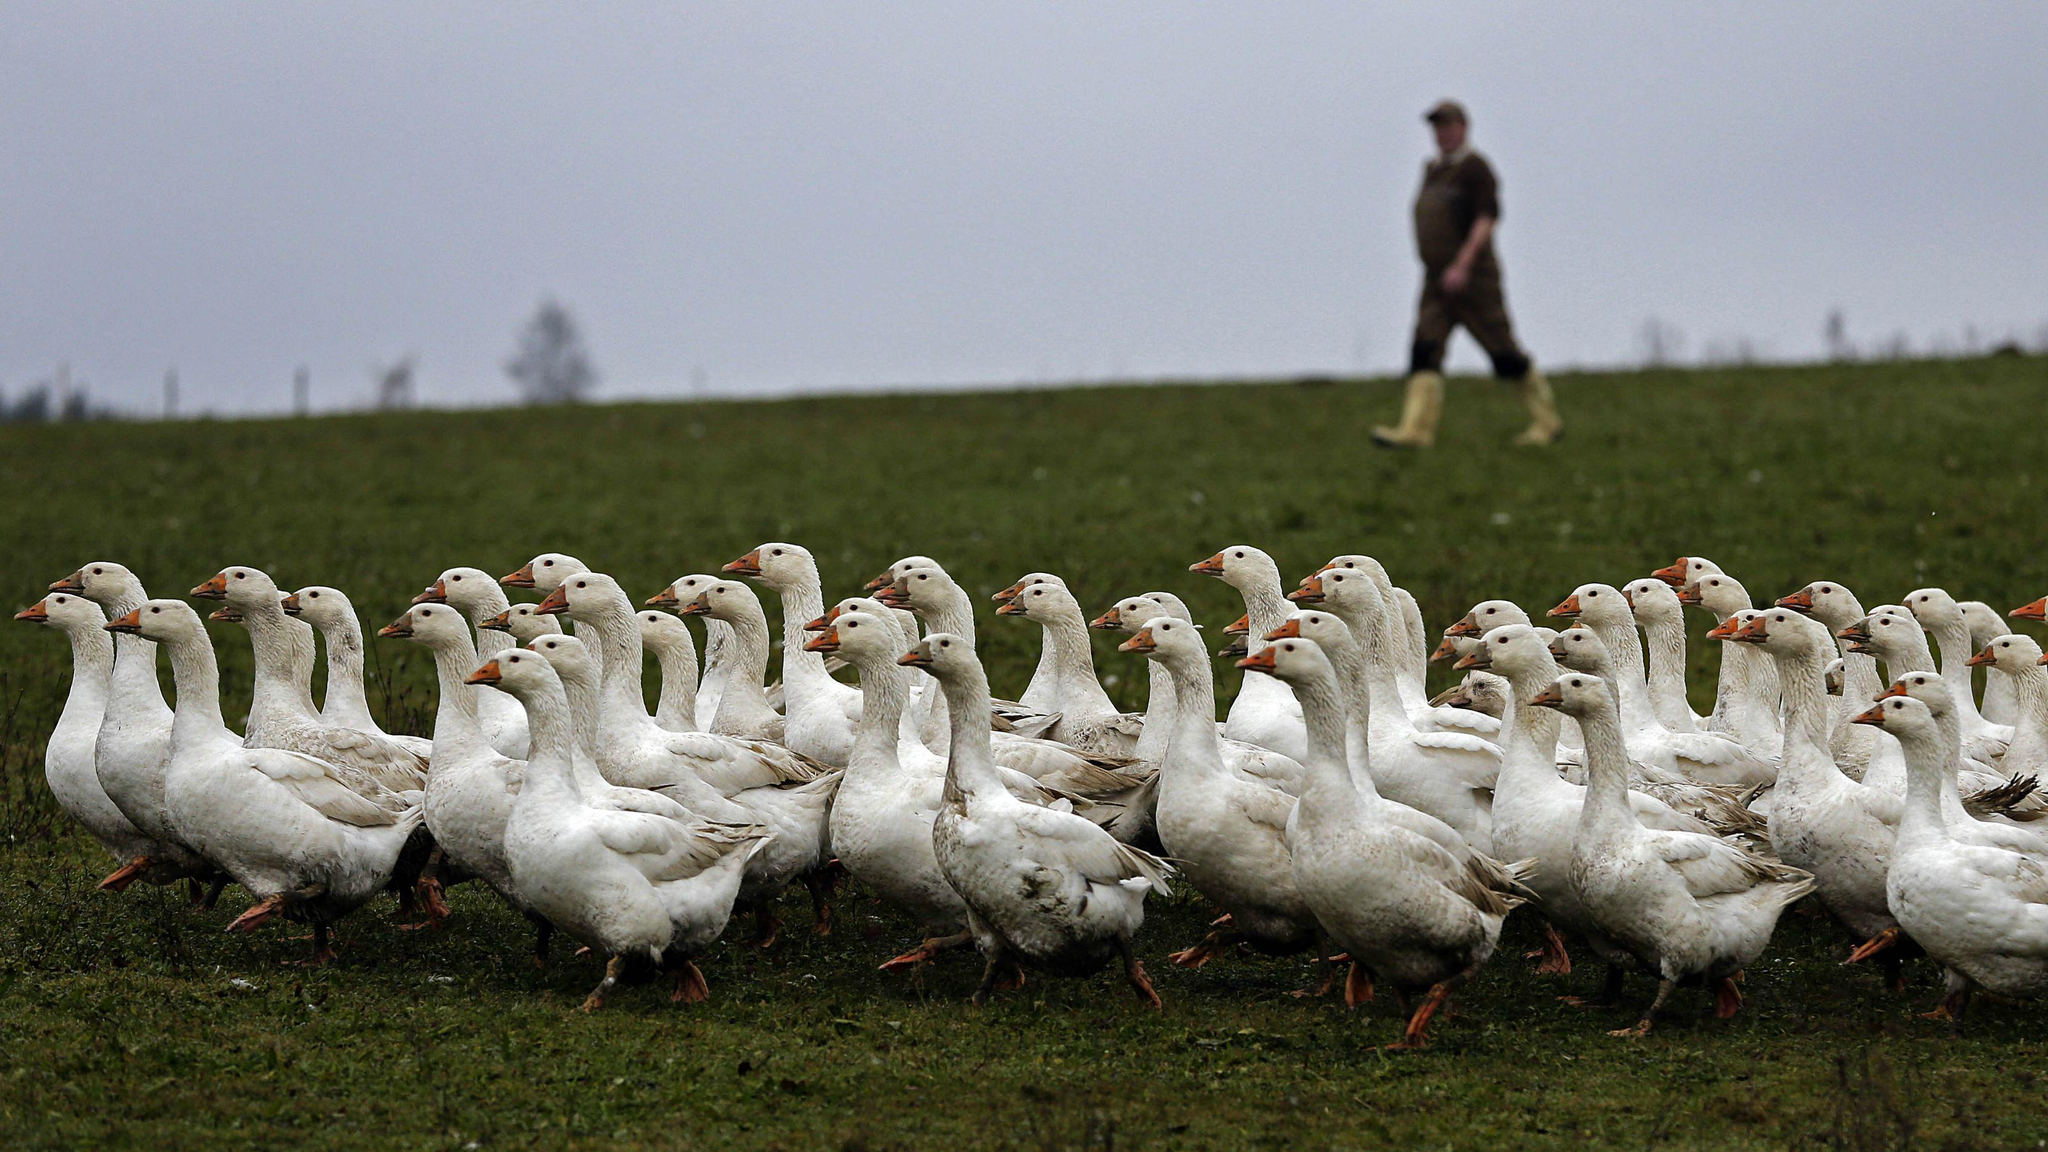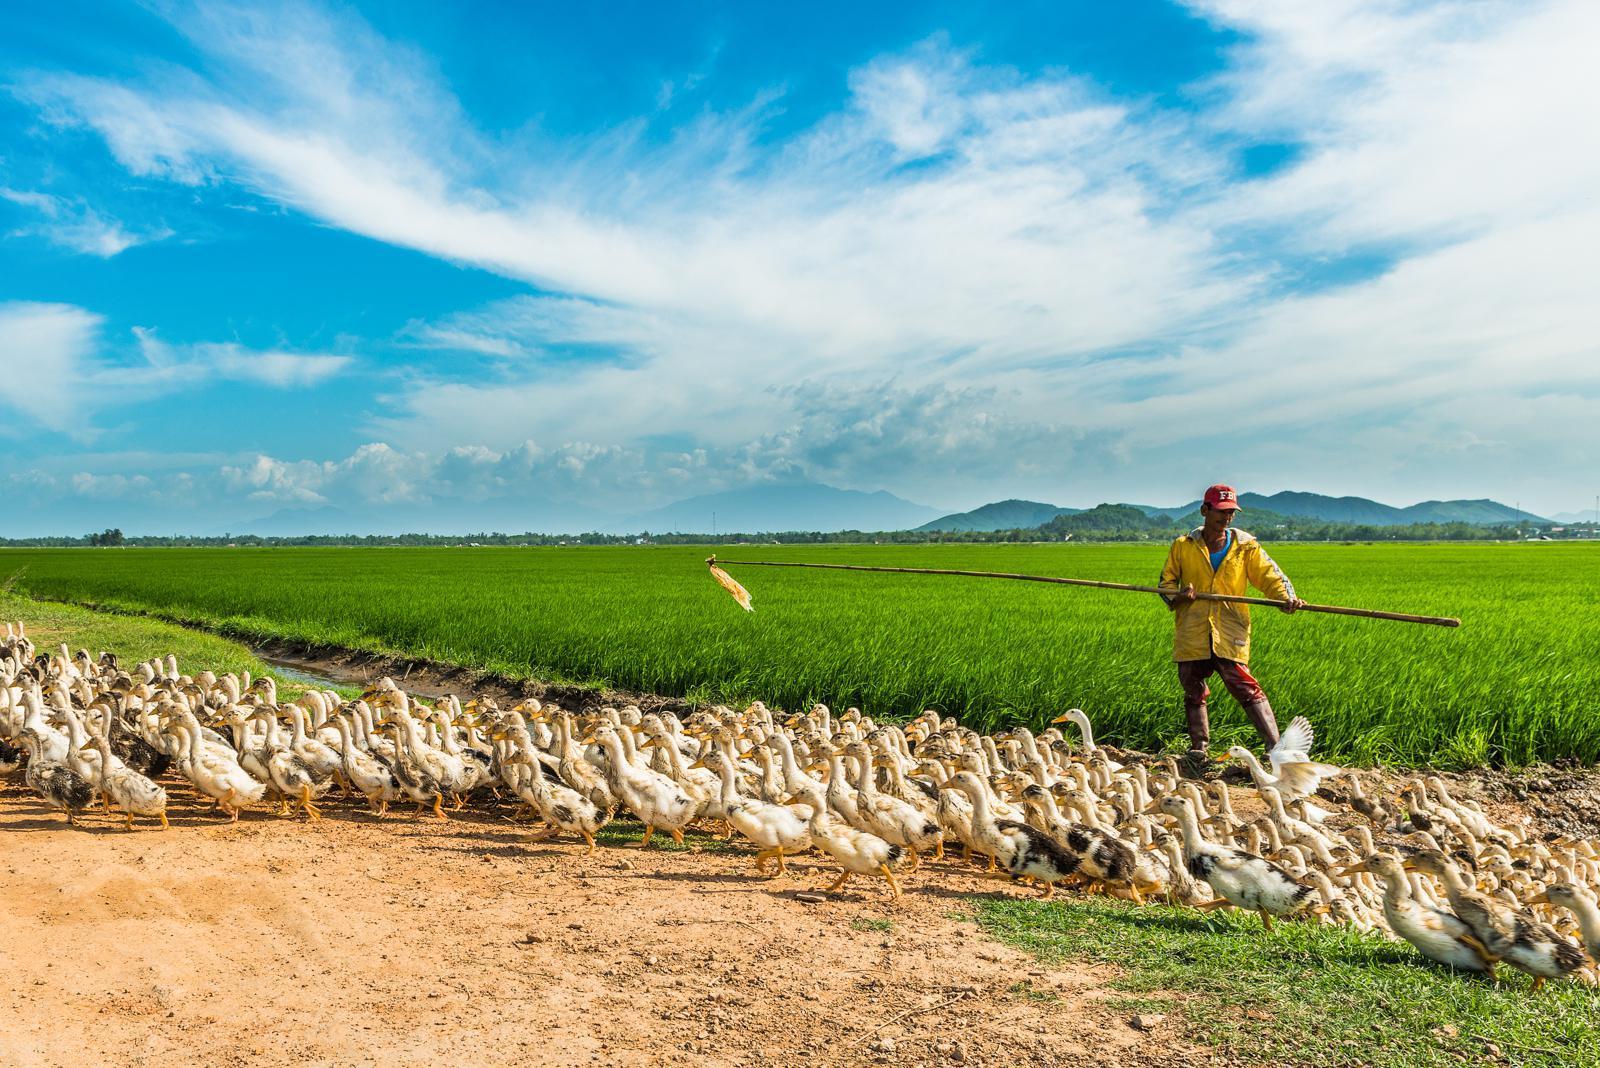The first image is the image on the left, the second image is the image on the right. Assess this claim about the two images: "An image shows a man holding out some type of stick while standing on a green field behind ducks.". Correct or not? Answer yes or no. Yes. The first image is the image on the left, the second image is the image on the right. Considering the images on both sides, is "One of the images shows a person holding a stick." valid? Answer yes or no. Yes. 